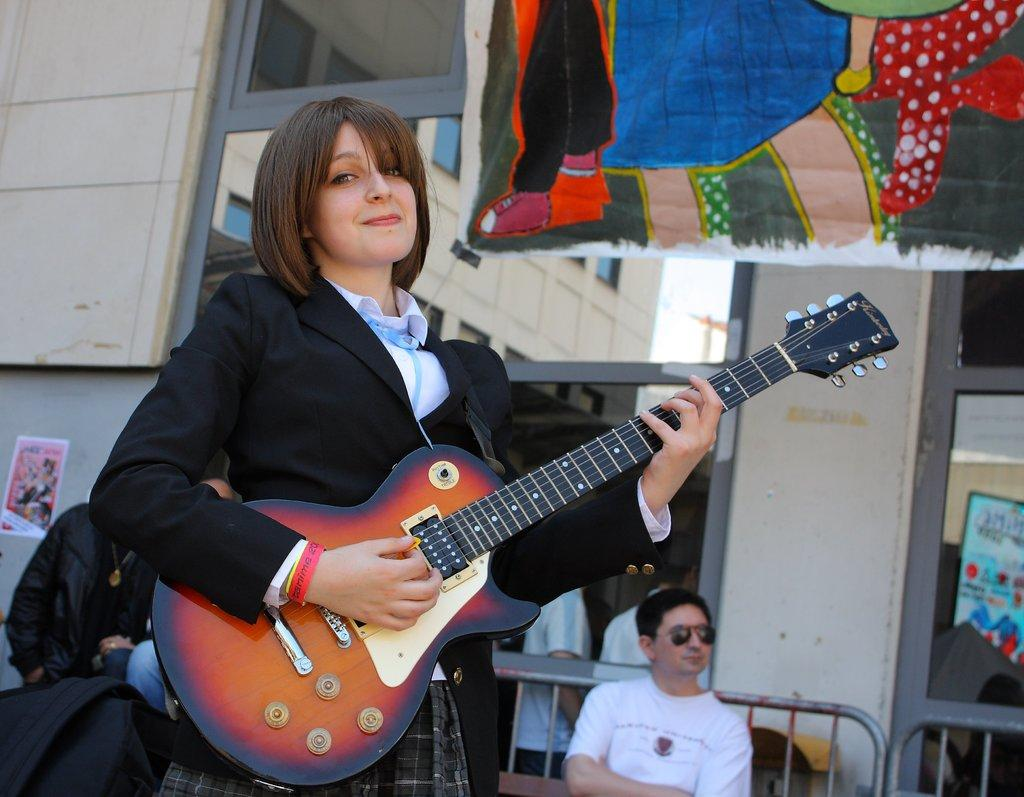What is the woman in the image holding? The woman is holding a guitar. What can be seen in the background of the image? There are people standing, a building, and a poster in the background of the image. How many people are visible in the background? There are people standing in the background of the image, but the exact number is not specified. What type of clock is hanging on the wall in the image? There is no clock visible in the image. How many dimes can be seen on the floor in the image? There are no dimes present in the image. 